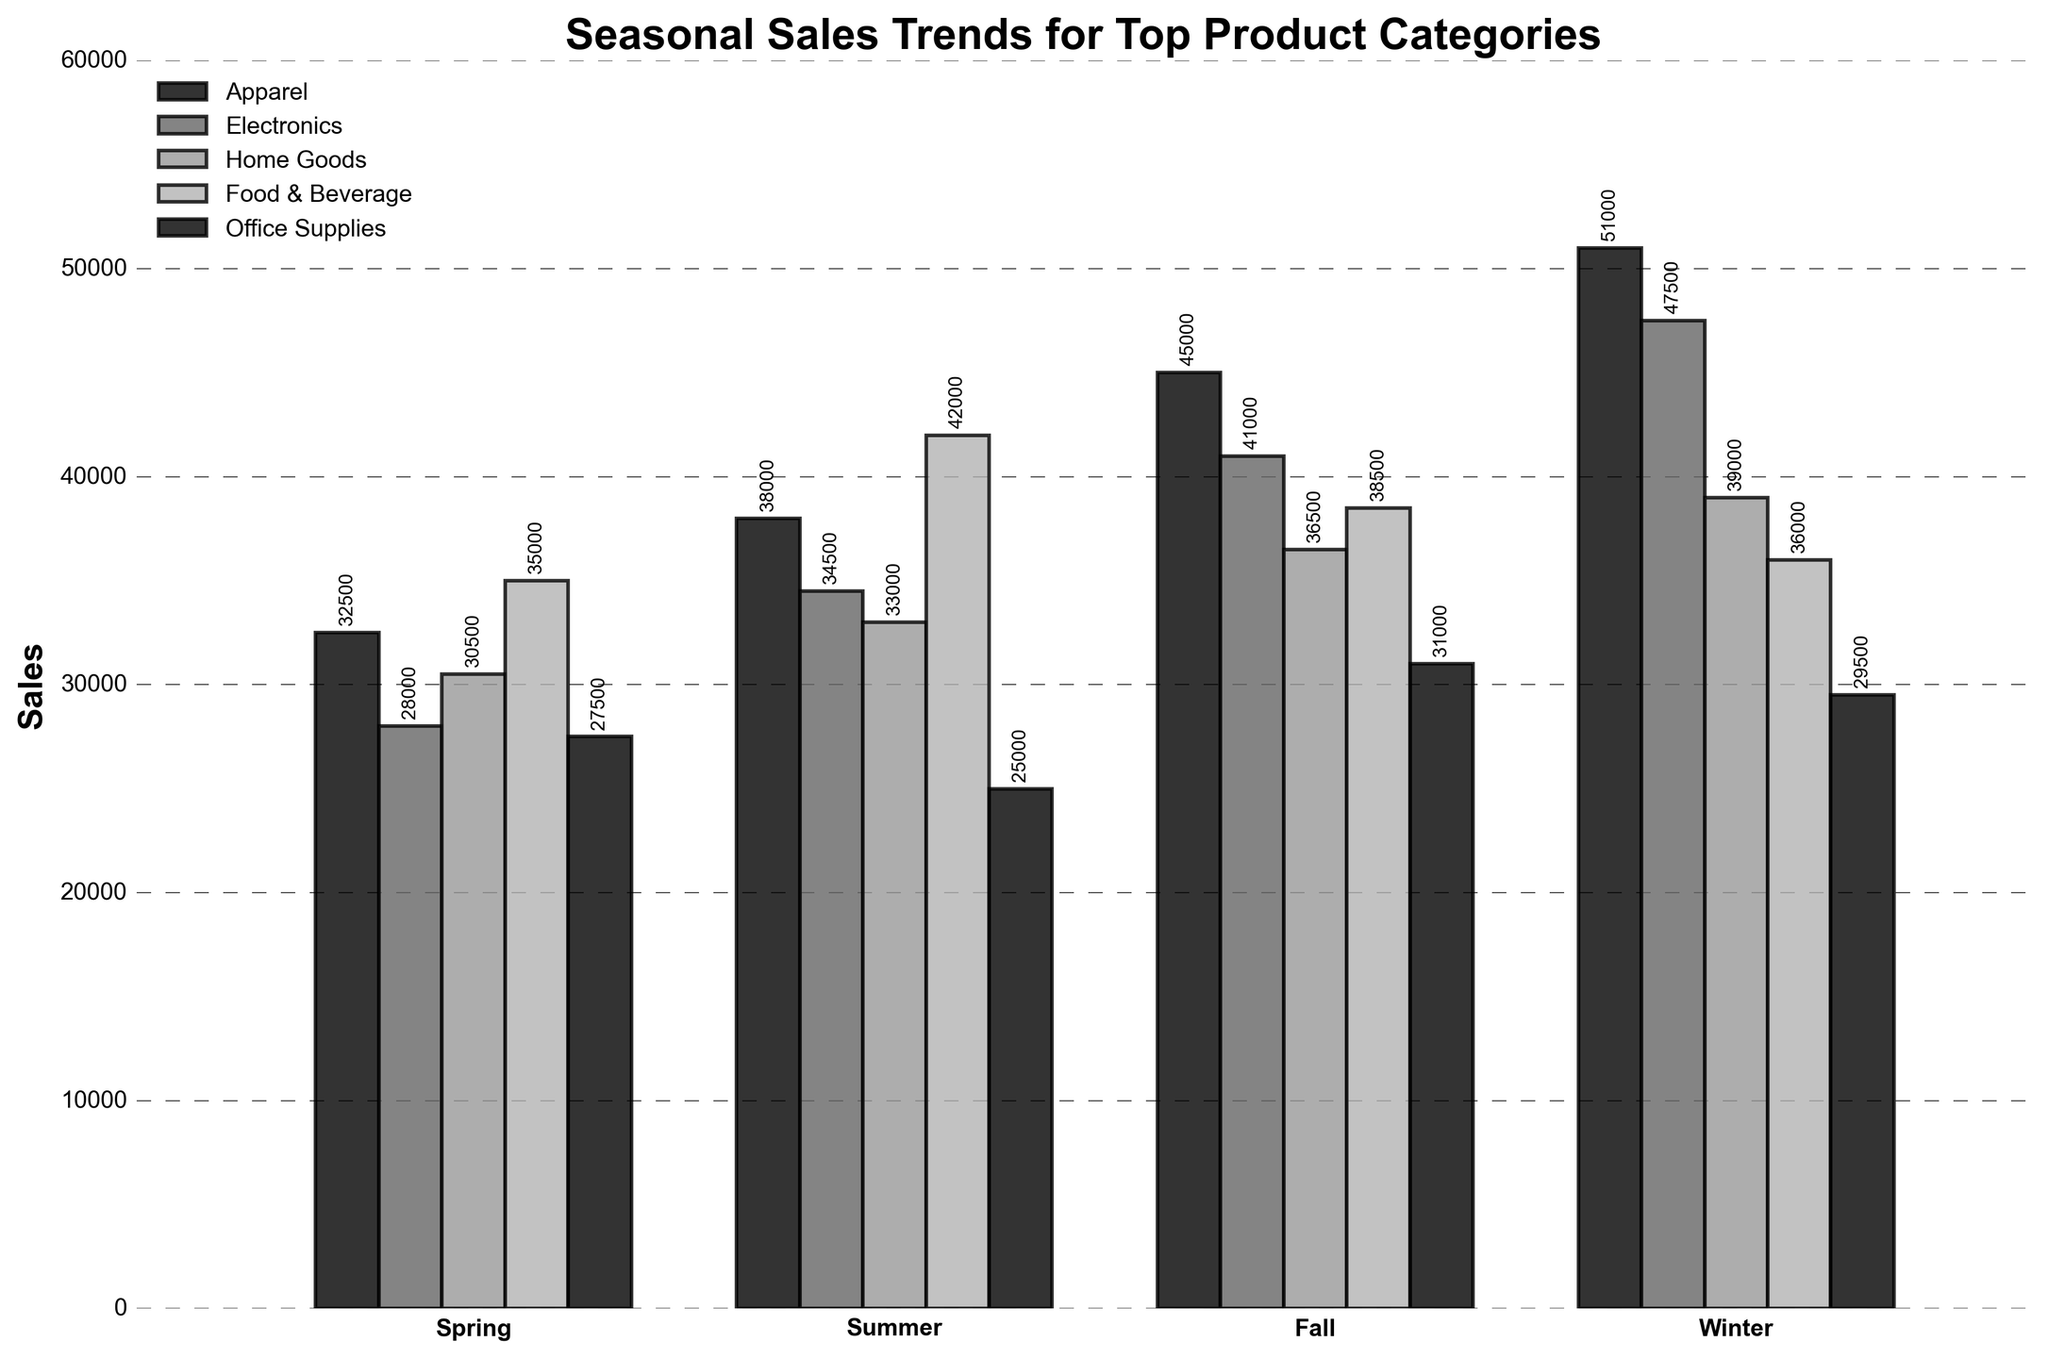What is the highest sales figure in the Winter season? In the Winter season, the highest bar is for Apparel, which reaches up to 51,000.
Answer: 51,000 Which season had the highest sales for Office Supplies? Comparing the bars for Office Supplies across all seasons, the tallest bar is in the Fall season, reaching 31,000.
Answer: Fall How does the Food & Beverage category's sales in Summer compare to Spring? The sales for Food & Beverage in Summer is 42,000 and in Spring is 35,000. The Summer sales are higher by 7,000.
Answer: Summer sales are 7,000 higher Which product category shows a consistent increase in sales from Spring to Winter? By observing the trend for each category across seasons, Apparel sales consistently increase from Spring (32,500) to Winter (51,000).
Answer: Apparel What is the sum of sales for Electronics in Spring and Summer? The sales for Electronics in Spring is 28,000 and in Summer is 34,500. Summing these values: 28,000 + 34,500 = 62,500.
Answer: 62,500 In which season does Home Goods reach its peak sales? The highest bar for Home Goods is in Winter, reaching 39,000.
Answer: Winter What is the difference between Apparel sales in Fall and Office Supplies sales in Winter? Apparel sales in Fall is 45,000, and Office Supplies sales in Winter is 29,500. The difference is 45,000 - 29,500 = 15,500.
Answer: 15,500 How do the Winter sales for Electronics compare to Winter sales for Home Goods? Electronics sales in Winter is 47,500, and Home Goods sales in Winter is 39,000. Electronics sales are higher by 8,500.
Answer: Electronics sales are 8,500 higher Which product category had the lowest sales in any season, and what were the sales figures? The lowest sales figure is for Office Supplies in Summer, which is 25,000.
Answer: Office Supplies, 25,000 What is the average sales figure for Food & Beverage across all seasons? The sales figures for Food & Beverage are 35,000 in Spring, 42,000 in Summer, 38,500 in Fall, and 36,000 in Winter. Summing these sales gives: 35,000 + 42,000 + 38,500 + 36,000 = 151,500. Dividing by 4 (number of seasons), we get 151,500 / 4 = 37,875.
Answer: 37,875 